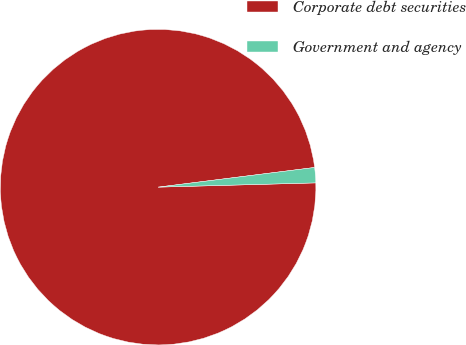Convert chart to OTSL. <chart><loc_0><loc_0><loc_500><loc_500><pie_chart><fcel>Corporate debt securities<fcel>Government and agency<nl><fcel>98.44%<fcel>1.56%<nl></chart> 